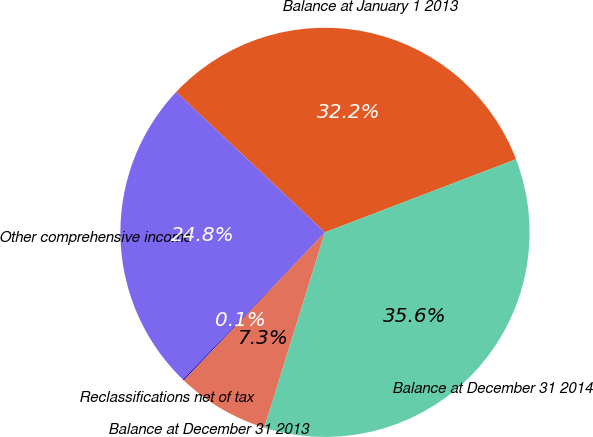Convert chart to OTSL. <chart><loc_0><loc_0><loc_500><loc_500><pie_chart><fcel>Balance at January 1 2013<fcel>Other comprehensive income<fcel>Reclassifications net of tax<fcel>Balance at December 31 2013<fcel>Balance at December 31 2014<nl><fcel>32.15%<fcel>24.82%<fcel>0.09%<fcel>7.33%<fcel>35.61%<nl></chart> 